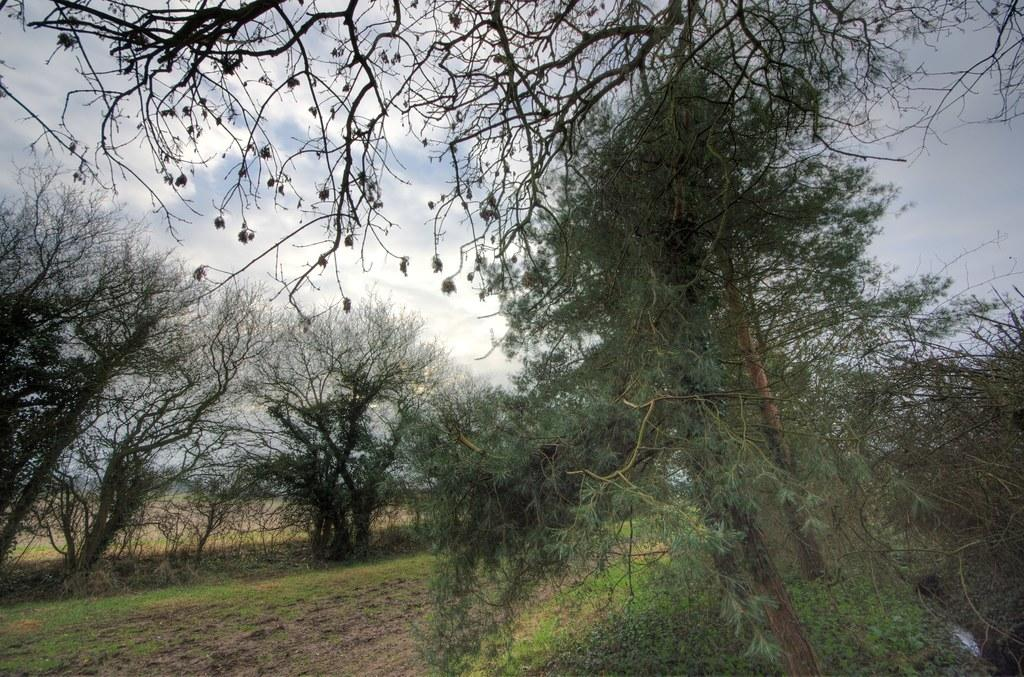What type of vegetation can be seen in the image? There is grass in the image. What other natural elements are present in the image? There are trees in the image. What can be seen in the background of the image? The sky is visible in the background of the image. What is the condition of the sky in the image? Clouds are present in the sky. What trick is the grass performing in the image? There is no trick being performed by the grass in the image; it is simply grass. 